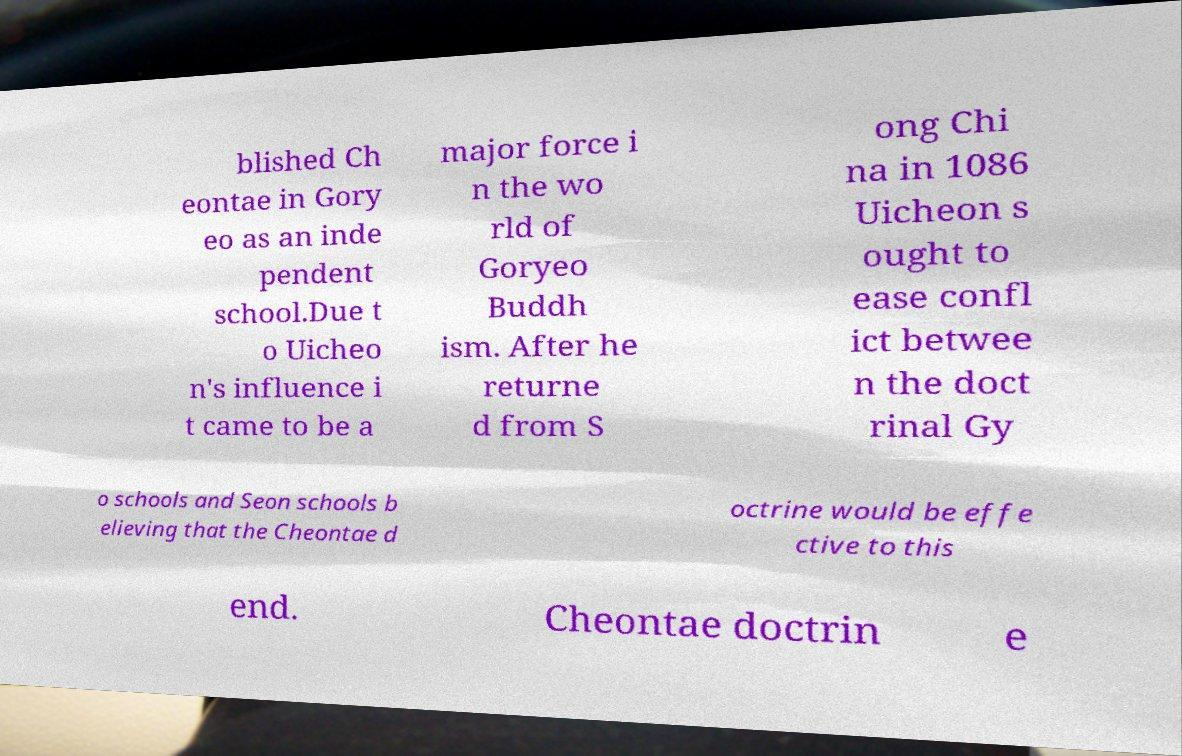Please identify and transcribe the text found in this image. blished Ch eontae in Gory eo as an inde pendent school.Due t o Uicheo n's influence i t came to be a major force i n the wo rld of Goryeo Buddh ism. After he returne d from S ong Chi na in 1086 Uicheon s ought to ease confl ict betwee n the doct rinal Gy o schools and Seon schools b elieving that the Cheontae d octrine would be effe ctive to this end. Cheontae doctrin e 